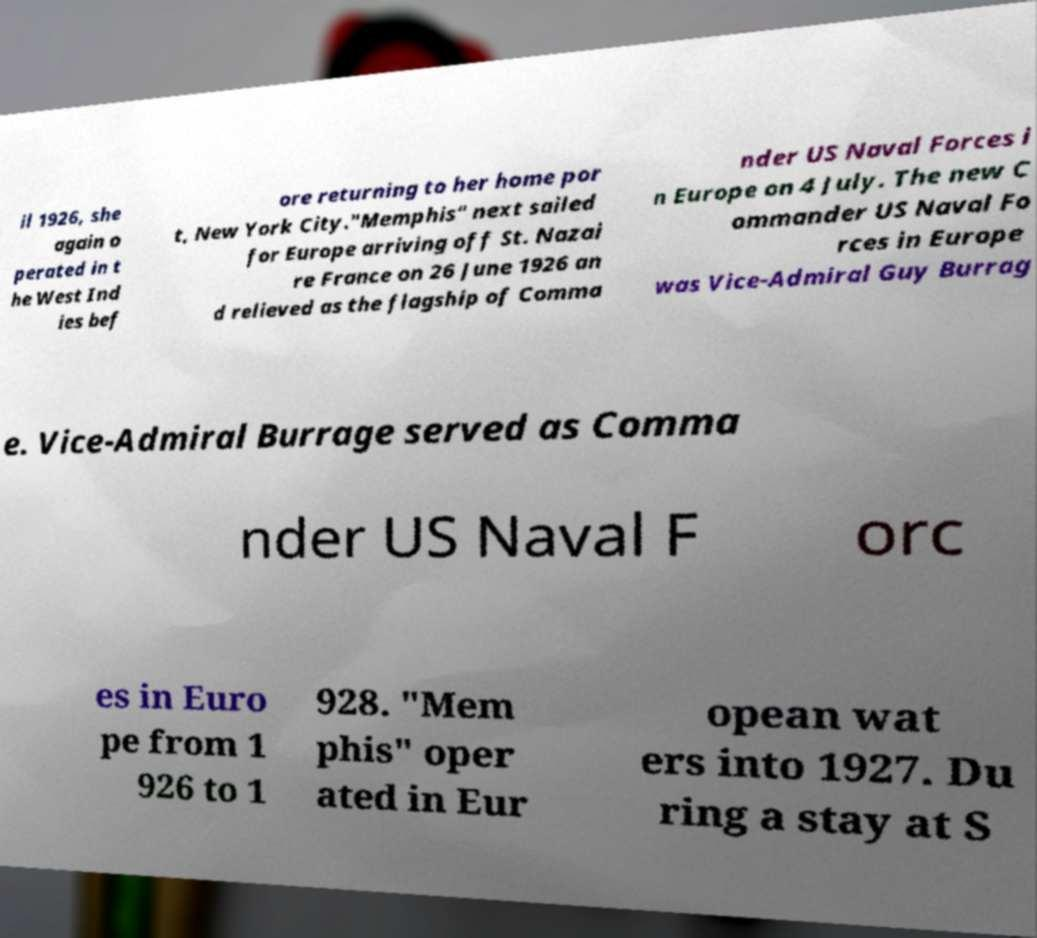Could you assist in decoding the text presented in this image and type it out clearly? il 1926, she again o perated in t he West Ind ies bef ore returning to her home por t, New York City."Memphis" next sailed for Europe arriving off St. Nazai re France on 26 June 1926 an d relieved as the flagship of Comma nder US Naval Forces i n Europe on 4 July. The new C ommander US Naval Fo rces in Europe was Vice-Admiral Guy Burrag e. Vice-Admiral Burrage served as Comma nder US Naval F orc es in Euro pe from 1 926 to 1 928. "Mem phis" oper ated in Eur opean wat ers into 1927. Du ring a stay at S 